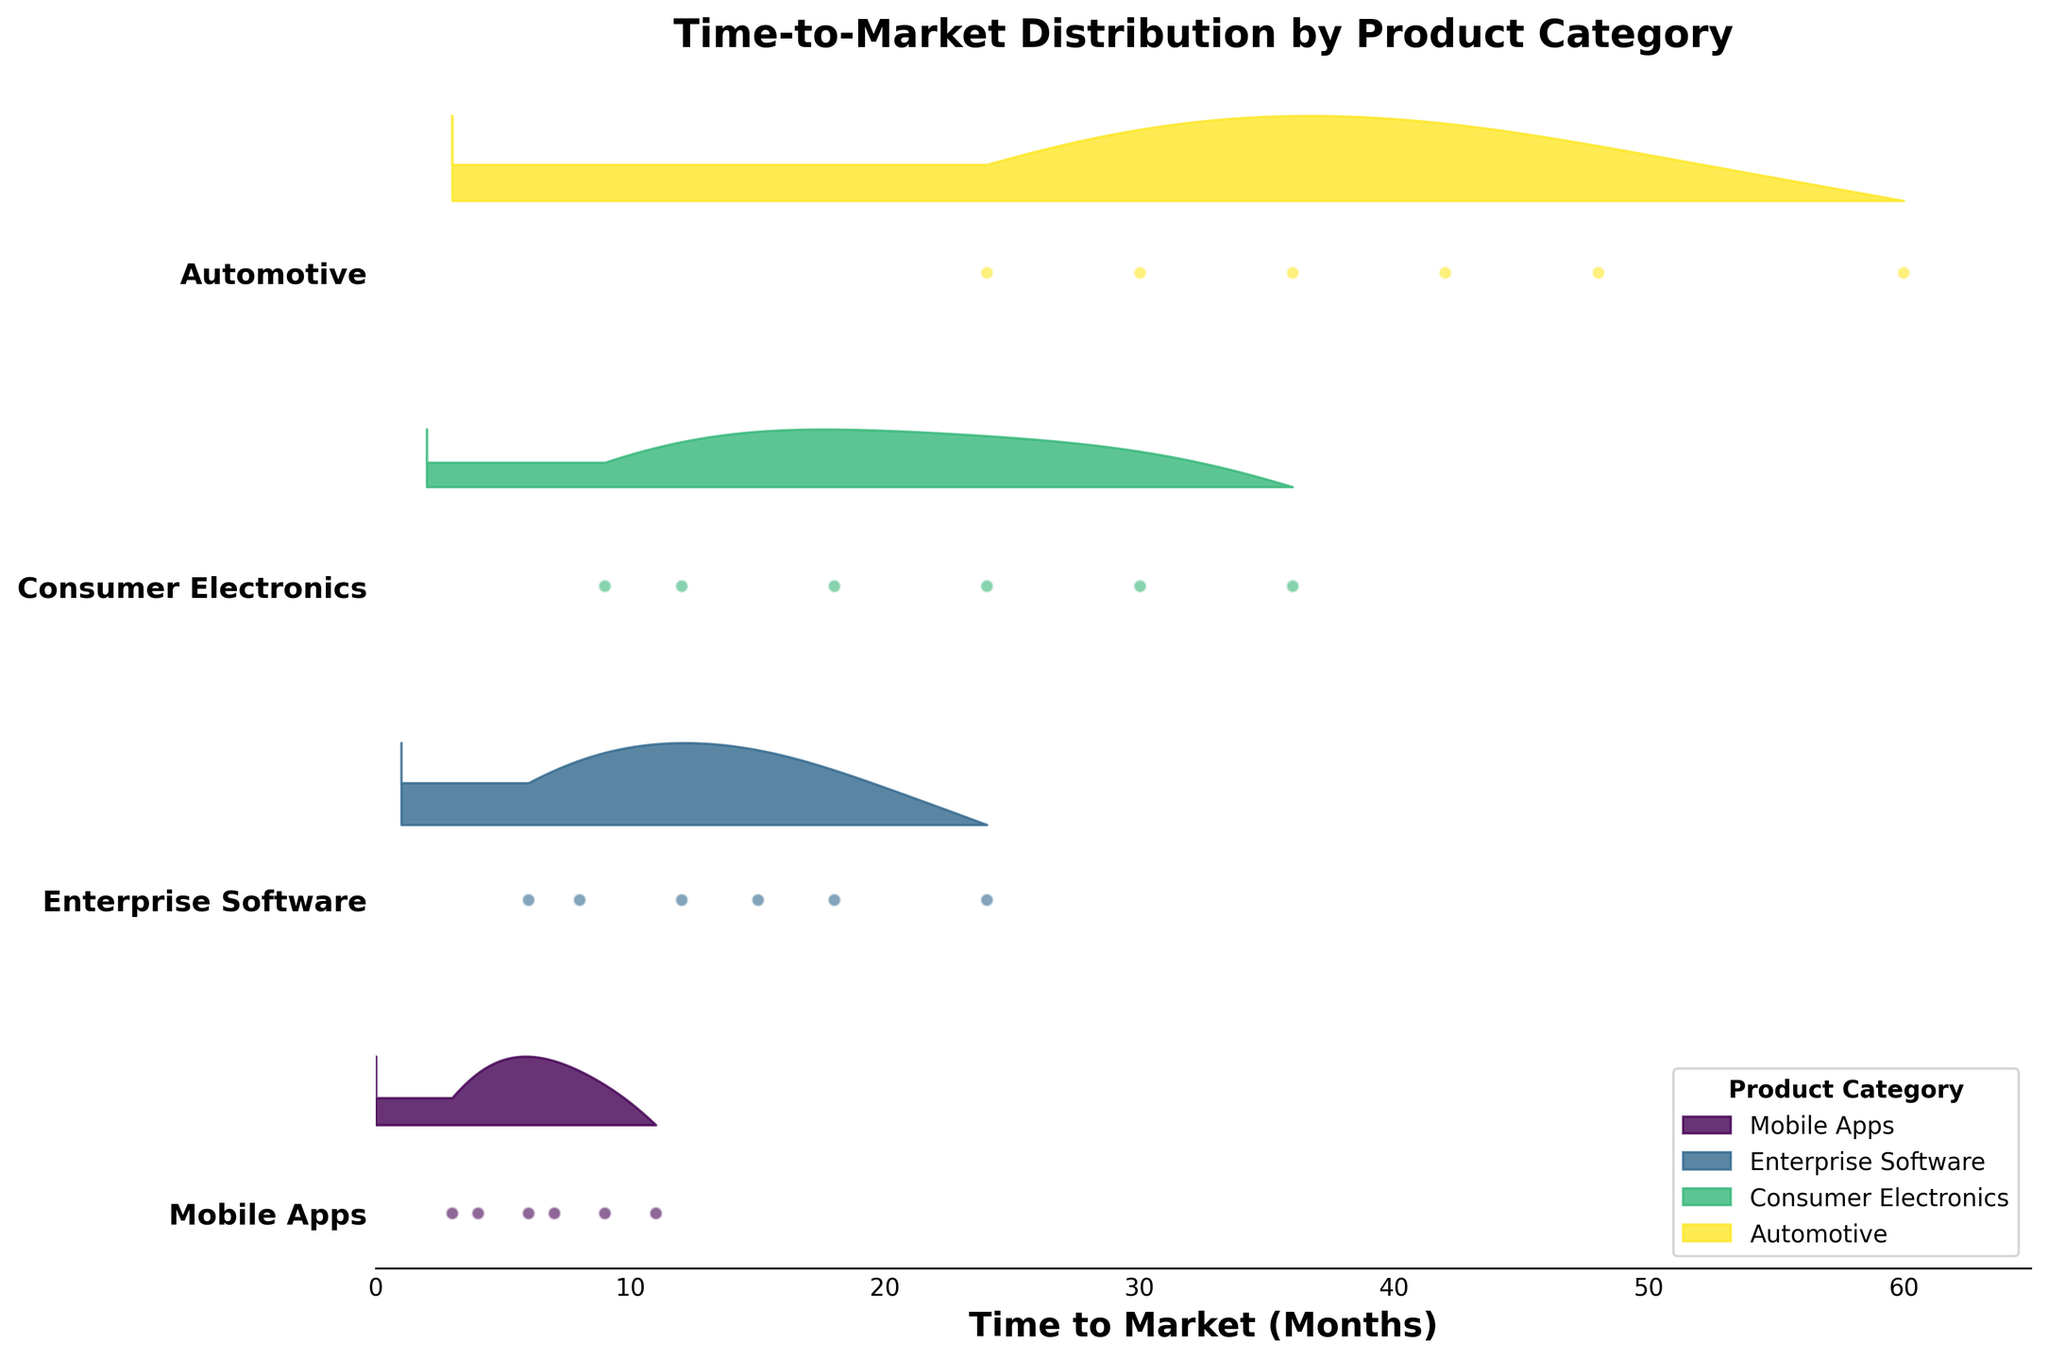what is the title of the figure? The title of the figure is directly displayed on top of it, and it's written in bold fonts.
Answer: Time-to-Market Distribution by Product Category Which product category has the most extensive time-to-market range? By examining the width of the density plot for various categories, we see that the "Automotive" category stretches the furthest on the x-axis.
Answer: Automotive What is the average time-to-market for Medium complexity in Mobile Apps? Identify the data points for Medium complexity under Mobile Apps, which are 6 and 7 months. Then calculate the average: (6 + 7) / 2 = 6.5 months.
Answer: 6.5 months Which product category takes the least time to market for the High complexity level? From the density plot, the shortest time-to-market for High complexity is visible for the Mobile Apps category, initiating around 9 months.
Answer: Mobile Apps How does the time-to-market for Low complexity Consumer Electronics compare to Low complexity Enterprise Software? By comparing their density plots, Low complexity Consumer Electronics ranges from 9 to 12 months, whereas Low complexity Enterprise Software ranges from 6 to 8 months.
Answer: Consumer Electronics is longer What is the maximum time-to-market for High complexity Automotive products? Looking at the horizontal range for High complexity Automotive, the highest point extends to 60 months.
Answer: 60 months Which category shows the greatest density for Medium complexity around 18 months? By analyzing where density peaks around 18 months for the Medium complexity products, it shows the highest density peak for Consumer Electronics.
Answer: Consumer Electronics Are there any categories where the time-to-market for Low complexity overlaps with Medium complexity? Checking the density plots of each category, Mobile Apps and Enterprise Software have overlapping ranges between Low and Medium complexity.
Answer: Yes What is the difference in maximum time-to-market between High and Medium complexity in Enterprise Software? High complexity in Enterprise Software has a maximum of 24 months, and Medium has 15 months. The difference is 24 - 15 = 9 months.
Answer: 9 months In terms of the spread, which category appears to be the most consistent in time-to-market? By evaluating the tightness of the density distribution, Mobile Apps show the most consistent spread across different complexities.
Answer: Mobile Apps 